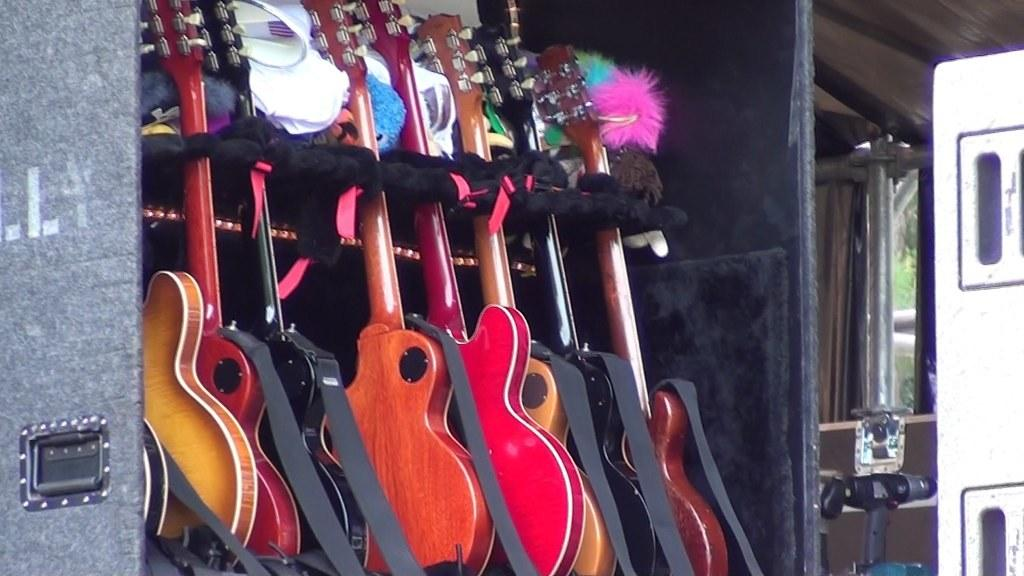How many guitars are present in the image? There are seven guitars in the image. What can be observed about the guitars in terms of their appearance? The guitars are of different colors. What type of boot is being used to aid the guitars' digestion in the image? There is no boot or digestion process present in the image; it features seven guitars of different colors. Can you describe the flight capabilities of the guitars in the image? Guitars do not have flight capabilities, as they are musical instruments and not aircraft. 